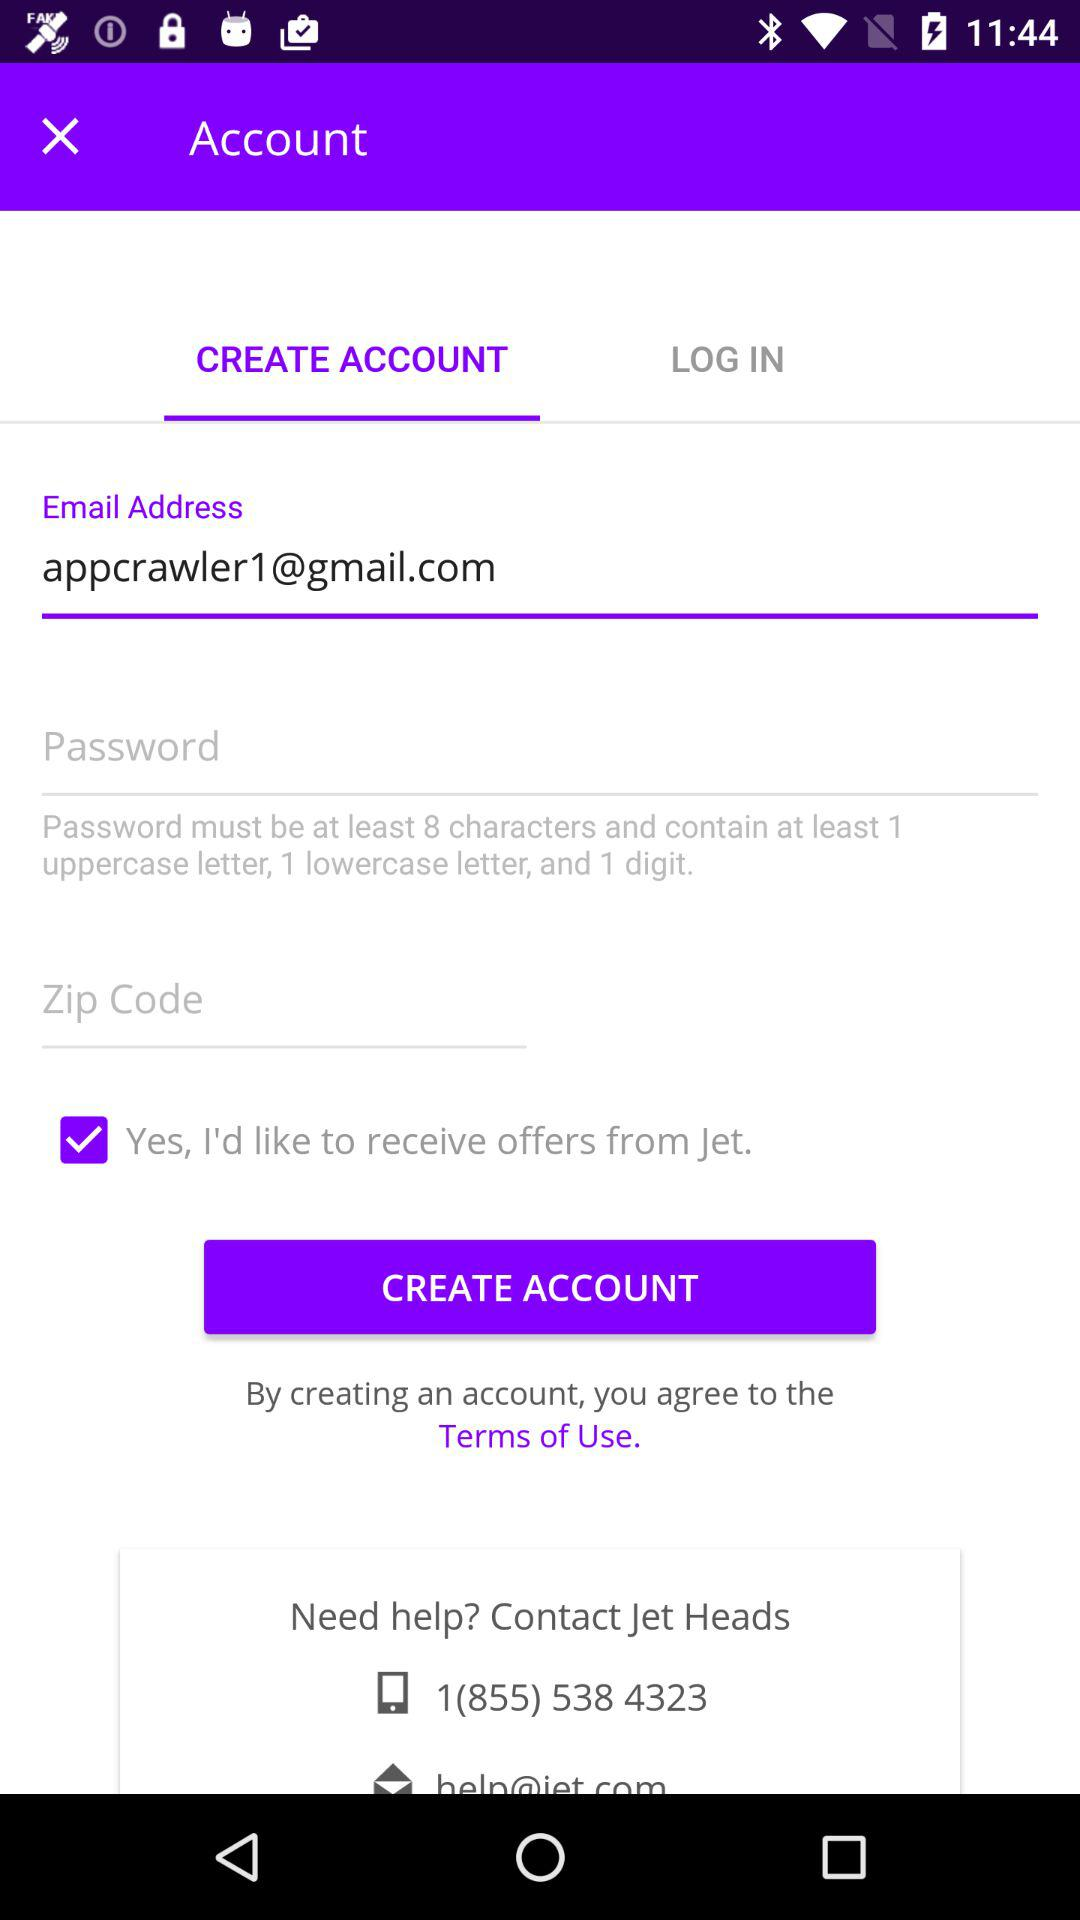What is the selected option? The selected option is "CREATE ACCOUNT". 